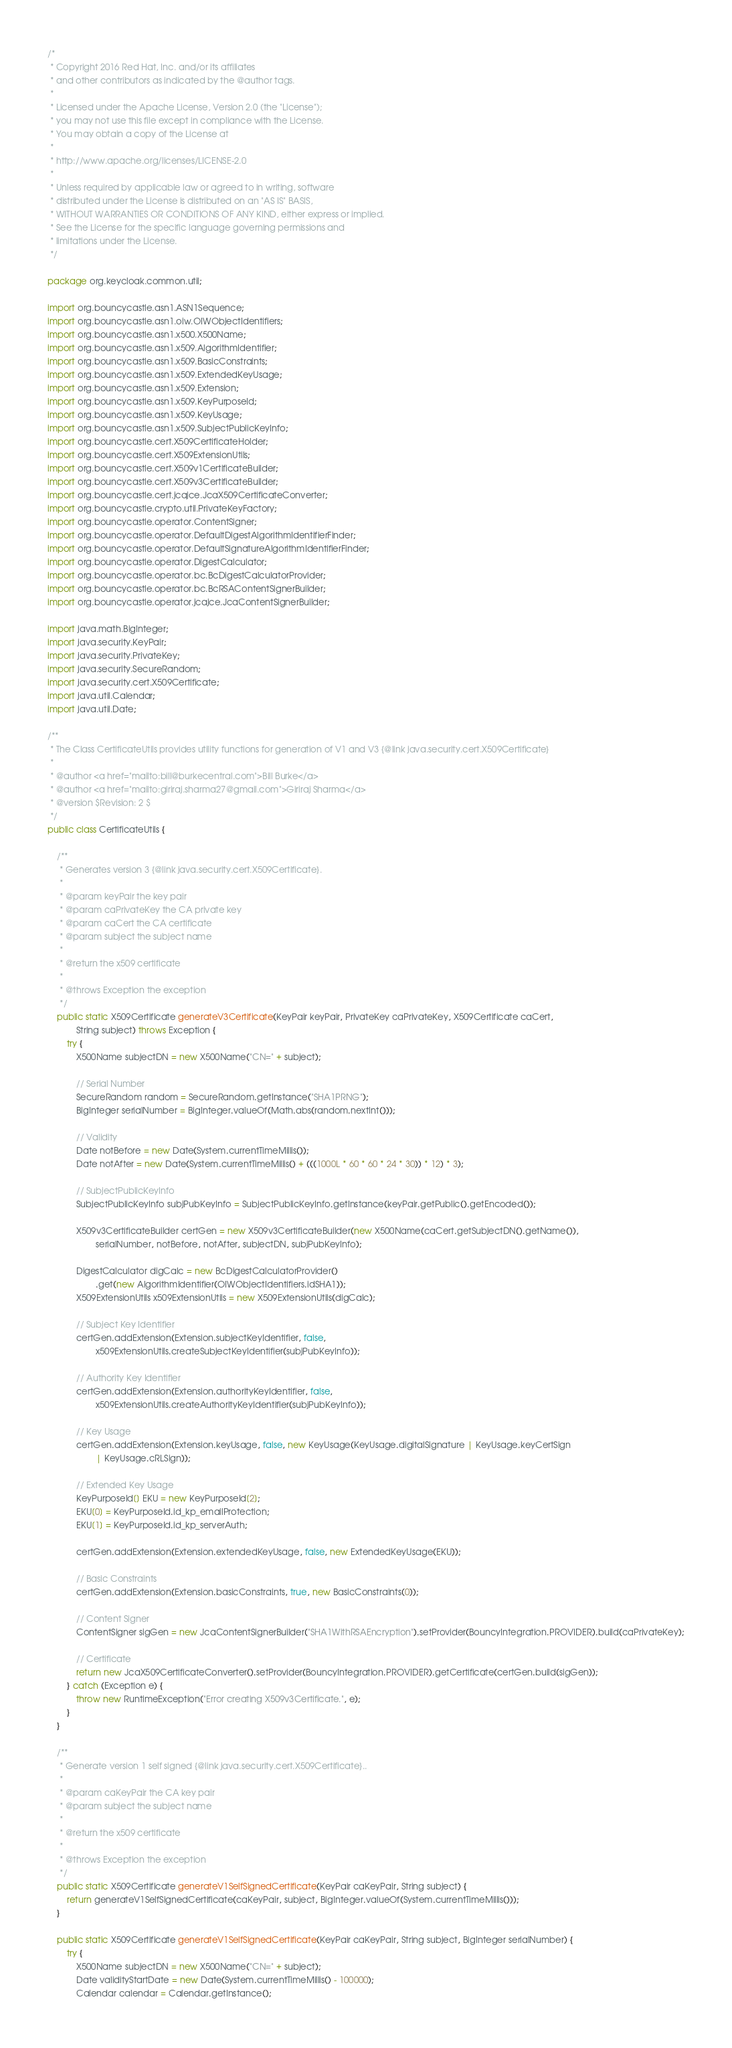Convert code to text. <code><loc_0><loc_0><loc_500><loc_500><_Java_>/*
 * Copyright 2016 Red Hat, Inc. and/or its affiliates
 * and other contributors as indicated by the @author tags.
 *
 * Licensed under the Apache License, Version 2.0 (the "License");
 * you may not use this file except in compliance with the License.
 * You may obtain a copy of the License at
 *
 * http://www.apache.org/licenses/LICENSE-2.0
 *
 * Unless required by applicable law or agreed to in writing, software
 * distributed under the License is distributed on an "AS IS" BASIS,
 * WITHOUT WARRANTIES OR CONDITIONS OF ANY KIND, either express or implied.
 * See the License for the specific language governing permissions and
 * limitations under the License.
 */

package org.keycloak.common.util;

import org.bouncycastle.asn1.ASN1Sequence;
import org.bouncycastle.asn1.oiw.OIWObjectIdentifiers;
import org.bouncycastle.asn1.x500.X500Name;
import org.bouncycastle.asn1.x509.AlgorithmIdentifier;
import org.bouncycastle.asn1.x509.BasicConstraints;
import org.bouncycastle.asn1.x509.ExtendedKeyUsage;
import org.bouncycastle.asn1.x509.Extension;
import org.bouncycastle.asn1.x509.KeyPurposeId;
import org.bouncycastle.asn1.x509.KeyUsage;
import org.bouncycastle.asn1.x509.SubjectPublicKeyInfo;
import org.bouncycastle.cert.X509CertificateHolder;
import org.bouncycastle.cert.X509ExtensionUtils;
import org.bouncycastle.cert.X509v1CertificateBuilder;
import org.bouncycastle.cert.X509v3CertificateBuilder;
import org.bouncycastle.cert.jcajce.JcaX509CertificateConverter;
import org.bouncycastle.crypto.util.PrivateKeyFactory;
import org.bouncycastle.operator.ContentSigner;
import org.bouncycastle.operator.DefaultDigestAlgorithmIdentifierFinder;
import org.bouncycastle.operator.DefaultSignatureAlgorithmIdentifierFinder;
import org.bouncycastle.operator.DigestCalculator;
import org.bouncycastle.operator.bc.BcDigestCalculatorProvider;
import org.bouncycastle.operator.bc.BcRSAContentSignerBuilder;
import org.bouncycastle.operator.jcajce.JcaContentSignerBuilder;

import java.math.BigInteger;
import java.security.KeyPair;
import java.security.PrivateKey;
import java.security.SecureRandom;
import java.security.cert.X509Certificate;
import java.util.Calendar;
import java.util.Date;

/**
 * The Class CertificateUtils provides utility functions for generation of V1 and V3 {@link java.security.cert.X509Certificate}
 *
 * @author <a href="mailto:bill@burkecentral.com">Bill Burke</a>
 * @author <a href="mailto:giriraj.sharma27@gmail.com">Giriraj Sharma</a>
 * @version $Revision: 2 $
 */
public class CertificateUtils {

    /**
     * Generates version 3 {@link java.security.cert.X509Certificate}.
     *
     * @param keyPair the key pair
     * @param caPrivateKey the CA private key
     * @param caCert the CA certificate
     * @param subject the subject name
     * 
     * @return the x509 certificate
     * 
     * @throws Exception the exception
     */
    public static X509Certificate generateV3Certificate(KeyPair keyPair, PrivateKey caPrivateKey, X509Certificate caCert,
            String subject) throws Exception {
        try {
            X500Name subjectDN = new X500Name("CN=" + subject);

            // Serial Number
            SecureRandom random = SecureRandom.getInstance("SHA1PRNG");
            BigInteger serialNumber = BigInteger.valueOf(Math.abs(random.nextInt()));

            // Validity
            Date notBefore = new Date(System.currentTimeMillis());
            Date notAfter = new Date(System.currentTimeMillis() + (((1000L * 60 * 60 * 24 * 30)) * 12) * 3);

            // SubjectPublicKeyInfo
            SubjectPublicKeyInfo subjPubKeyInfo = SubjectPublicKeyInfo.getInstance(keyPair.getPublic().getEncoded());

            X509v3CertificateBuilder certGen = new X509v3CertificateBuilder(new X500Name(caCert.getSubjectDN().getName()),
                    serialNumber, notBefore, notAfter, subjectDN, subjPubKeyInfo);

            DigestCalculator digCalc = new BcDigestCalculatorProvider()
                    .get(new AlgorithmIdentifier(OIWObjectIdentifiers.idSHA1));
            X509ExtensionUtils x509ExtensionUtils = new X509ExtensionUtils(digCalc);

            // Subject Key Identifier
            certGen.addExtension(Extension.subjectKeyIdentifier, false,
                    x509ExtensionUtils.createSubjectKeyIdentifier(subjPubKeyInfo));

            // Authority Key Identifier
            certGen.addExtension(Extension.authorityKeyIdentifier, false,
                    x509ExtensionUtils.createAuthorityKeyIdentifier(subjPubKeyInfo));

            // Key Usage
            certGen.addExtension(Extension.keyUsage, false, new KeyUsage(KeyUsage.digitalSignature | KeyUsage.keyCertSign
                    | KeyUsage.cRLSign));

            // Extended Key Usage
            KeyPurposeId[] EKU = new KeyPurposeId[2];
            EKU[0] = KeyPurposeId.id_kp_emailProtection;
            EKU[1] = KeyPurposeId.id_kp_serverAuth;

            certGen.addExtension(Extension.extendedKeyUsage, false, new ExtendedKeyUsage(EKU));

            // Basic Constraints
            certGen.addExtension(Extension.basicConstraints, true, new BasicConstraints(0));

            // Content Signer
            ContentSigner sigGen = new JcaContentSignerBuilder("SHA1WithRSAEncryption").setProvider(BouncyIntegration.PROVIDER).build(caPrivateKey);

            // Certificate
            return new JcaX509CertificateConverter().setProvider(BouncyIntegration.PROVIDER).getCertificate(certGen.build(sigGen));
        } catch (Exception e) {
            throw new RuntimeException("Error creating X509v3Certificate.", e);
        }
    }

    /**
     * Generate version 1 self signed {@link java.security.cert.X509Certificate}..
     *
     * @param caKeyPair the CA key pair
     * @param subject the subject name
     * 
     * @return the x509 certificate
     * 
     * @throws Exception the exception
     */
    public static X509Certificate generateV1SelfSignedCertificate(KeyPair caKeyPair, String subject) {
        return generateV1SelfSignedCertificate(caKeyPair, subject, BigInteger.valueOf(System.currentTimeMillis()));
    }

    public static X509Certificate generateV1SelfSignedCertificate(KeyPair caKeyPair, String subject, BigInteger serialNumber) {
        try {
            X500Name subjectDN = new X500Name("CN=" + subject);
            Date validityStartDate = new Date(System.currentTimeMillis() - 100000);
            Calendar calendar = Calendar.getInstance();</code> 